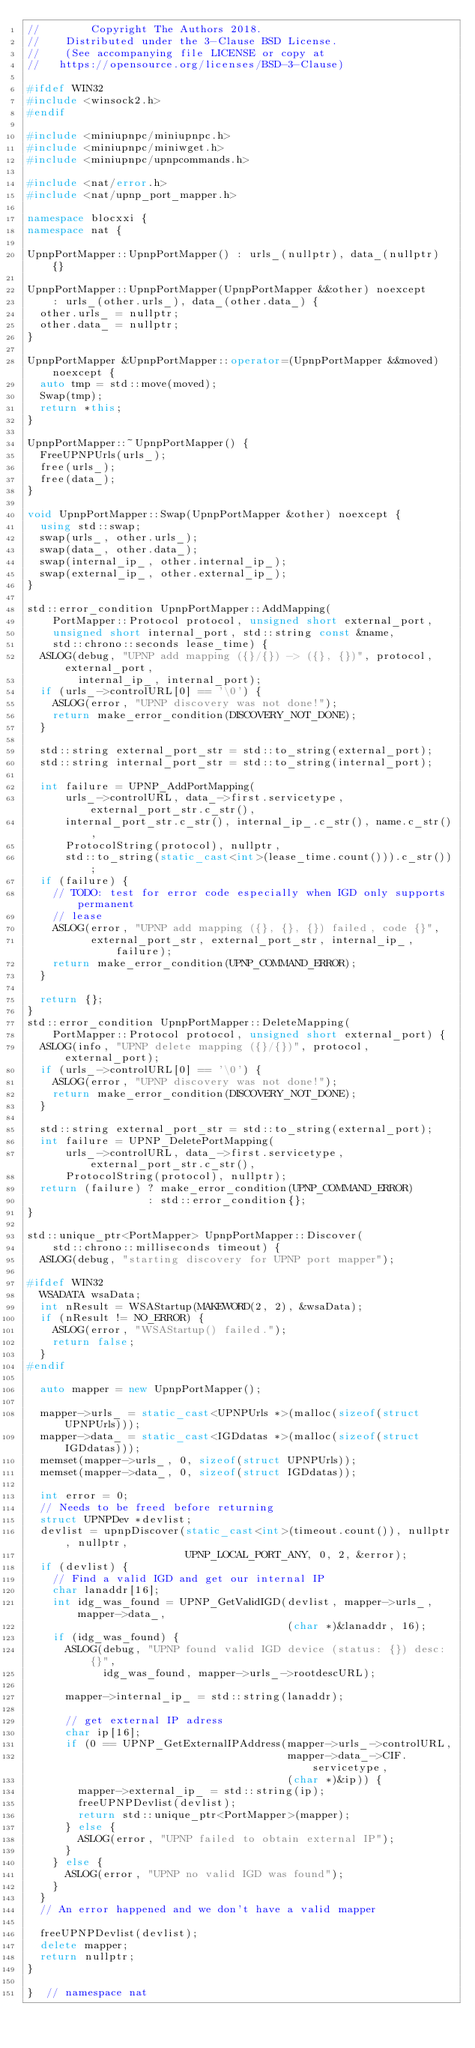<code> <loc_0><loc_0><loc_500><loc_500><_C++_>//        Copyright The Authors 2018.
//    Distributed under the 3-Clause BSD License.
//    (See accompanying file LICENSE or copy at
//   https://opensource.org/licenses/BSD-3-Clause)

#ifdef WIN32
#include <winsock2.h>
#endif

#include <miniupnpc/miniupnpc.h>
#include <miniupnpc/miniwget.h>
#include <miniupnpc/upnpcommands.h>

#include <nat/error.h>
#include <nat/upnp_port_mapper.h>

namespace blocxxi {
namespace nat {

UpnpPortMapper::UpnpPortMapper() : urls_(nullptr), data_(nullptr) {}

UpnpPortMapper::UpnpPortMapper(UpnpPortMapper &&other) noexcept
    : urls_(other.urls_), data_(other.data_) {
  other.urls_ = nullptr;
  other.data_ = nullptr;
}

UpnpPortMapper &UpnpPortMapper::operator=(UpnpPortMapper &&moved) noexcept {
  auto tmp = std::move(moved);
  Swap(tmp);
  return *this;
}

UpnpPortMapper::~UpnpPortMapper() {
  FreeUPNPUrls(urls_);
  free(urls_);
  free(data_);
}

void UpnpPortMapper::Swap(UpnpPortMapper &other) noexcept {
  using std::swap;
  swap(urls_, other.urls_);
  swap(data_, other.data_);
  swap(internal_ip_, other.internal_ip_);
  swap(external_ip_, other.external_ip_);
}

std::error_condition UpnpPortMapper::AddMapping(
    PortMapper::Protocol protocol, unsigned short external_port,
    unsigned short internal_port, std::string const &name,
    std::chrono::seconds lease_time) {
  ASLOG(debug, "UPNP add mapping ({}/{}) -> ({}, {})", protocol, external_port,
        internal_ip_, internal_port);
  if (urls_->controlURL[0] == '\0') {
    ASLOG(error, "UPNP discovery was not done!");
    return make_error_condition(DISCOVERY_NOT_DONE);
  }

  std::string external_port_str = std::to_string(external_port);
  std::string internal_port_str = std::to_string(internal_port);

  int failure = UPNP_AddPortMapping(
      urls_->controlURL, data_->first.servicetype, external_port_str.c_str(),
      internal_port_str.c_str(), internal_ip_.c_str(), name.c_str(),
      ProtocolString(protocol), nullptr,
      std::to_string(static_cast<int>(lease_time.count())).c_str());
  if (failure) {
    // TODO: test for error code especially when IGD only supports permanent
    // lease
    ASLOG(error, "UPNP add mapping ({}, {}, {}) failed, code {}",
          external_port_str, external_port_str, internal_ip_, failure);
    return make_error_condition(UPNP_COMMAND_ERROR);
  }

  return {};
}
std::error_condition UpnpPortMapper::DeleteMapping(
    PortMapper::Protocol protocol, unsigned short external_port) {
  ASLOG(info, "UPNP delete mapping ({}/{})", protocol, external_port);
  if (urls_->controlURL[0] == '\0') {
    ASLOG(error, "UPNP discovery was not done!");
    return make_error_condition(DISCOVERY_NOT_DONE);
  }

  std::string external_port_str = std::to_string(external_port);
  int failure = UPNP_DeletePortMapping(
      urls_->controlURL, data_->first.servicetype, external_port_str.c_str(),
      ProtocolString(protocol), nullptr);
  return (failure) ? make_error_condition(UPNP_COMMAND_ERROR)
                   : std::error_condition{};
}

std::unique_ptr<PortMapper> UpnpPortMapper::Discover(
    std::chrono::milliseconds timeout) {
  ASLOG(debug, "starting discovery for UPNP port mapper");

#ifdef WIN32
  WSADATA wsaData;
  int nResult = WSAStartup(MAKEWORD(2, 2), &wsaData);
  if (nResult != NO_ERROR) {
    ASLOG(error, "WSAStartup() failed.");
    return false;
  }
#endif

  auto mapper = new UpnpPortMapper();

  mapper->urls_ = static_cast<UPNPUrls *>(malloc(sizeof(struct UPNPUrls)));
  mapper->data_ = static_cast<IGDdatas *>(malloc(sizeof(struct IGDdatas)));
  memset(mapper->urls_, 0, sizeof(struct UPNPUrls));
  memset(mapper->data_, 0, sizeof(struct IGDdatas));

  int error = 0;
  // Needs to be freed before returning
  struct UPNPDev *devlist;
  devlist = upnpDiscover(static_cast<int>(timeout.count()), nullptr, nullptr,
                         UPNP_LOCAL_PORT_ANY, 0, 2, &error);
  if (devlist) {
    // Find a valid IGD and get our internal IP
    char lanaddr[16];
    int idg_was_found = UPNP_GetValidIGD(devlist, mapper->urls_, mapper->data_,
                                         (char *)&lanaddr, 16);
    if (idg_was_found) {
      ASLOG(debug, "UPNP found valid IGD device (status: {}) desc: {}",
            idg_was_found, mapper->urls_->rootdescURL);

      mapper->internal_ip_ = std::string(lanaddr);

      // get external IP adress
      char ip[16];
      if (0 == UPNP_GetExternalIPAddress(mapper->urls_->controlURL,
                                         mapper->data_->CIF.servicetype,
                                         (char *)&ip)) {
        mapper->external_ip_ = std::string(ip);
        freeUPNPDevlist(devlist);
        return std::unique_ptr<PortMapper>(mapper);
      } else {
        ASLOG(error, "UPNP failed to obtain external IP");
      }
    } else {
      ASLOG(error, "UPNP no valid IGD was found");
    }
  }
  // An error happened and we don't have a valid mapper

  freeUPNPDevlist(devlist);
  delete mapper;
  return nullptr;
}

}  // namespace nat</code> 